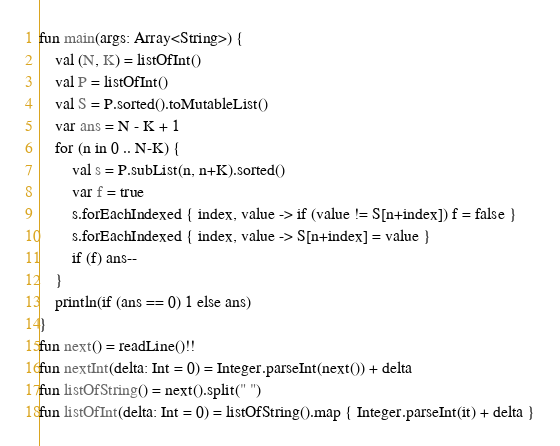Convert code to text. <code><loc_0><loc_0><loc_500><loc_500><_Kotlin_>fun main(args: Array<String>) {
    val (N, K) = listOfInt()
    val P = listOfInt()
    val S = P.sorted().toMutableList()
    var ans = N - K + 1
    for (n in 0 .. N-K) {
        val s = P.subList(n, n+K).sorted()
        var f = true
        s.forEachIndexed { index, value -> if (value != S[n+index]) f = false }
        s.forEachIndexed { index, value -> S[n+index] = value }
        if (f) ans--
    }
    println(if (ans == 0) 1 else ans)
}
fun next() = readLine()!!
fun nextInt(delta: Int = 0) = Integer.parseInt(next()) + delta
fun listOfString() = next().split(" ")
fun listOfInt(delta: Int = 0) = listOfString().map { Integer.parseInt(it) + delta }</code> 